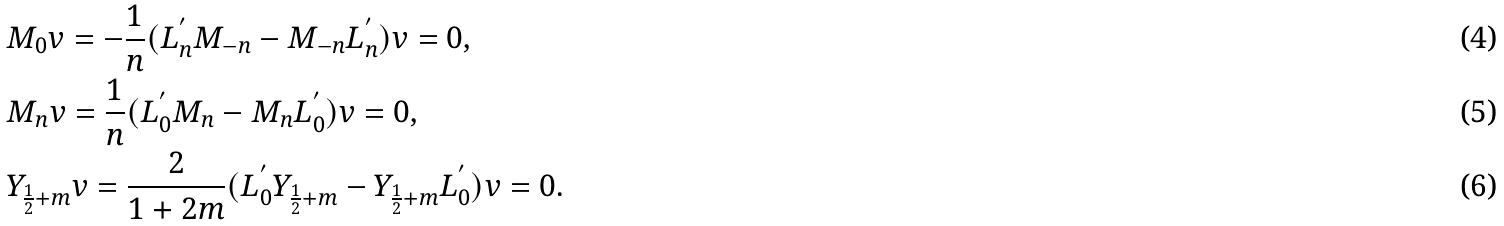<formula> <loc_0><loc_0><loc_500><loc_500>& M _ { 0 } v = - \frac { 1 } { n } ( L _ { n } ^ { ^ { \prime } } M _ { - n } - M _ { - n } L _ { n } ^ { ^ { \prime } } ) v = 0 , \\ & M _ { n } v = \frac { 1 } { n } ( L _ { 0 } ^ { ^ { \prime } } M _ { n } - M _ { n } L _ { 0 } ^ { ^ { \prime } } ) v = 0 , \\ & Y _ { \frac { 1 } { 2 } + m } v = \frac { 2 } { 1 + 2 m } ( L _ { 0 } ^ { ^ { \prime } } Y _ { \frac { 1 } { 2 } + m } - Y _ { \frac { 1 } { 2 } + m } L _ { 0 } ^ { ^ { \prime } } ) v = 0 .</formula> 